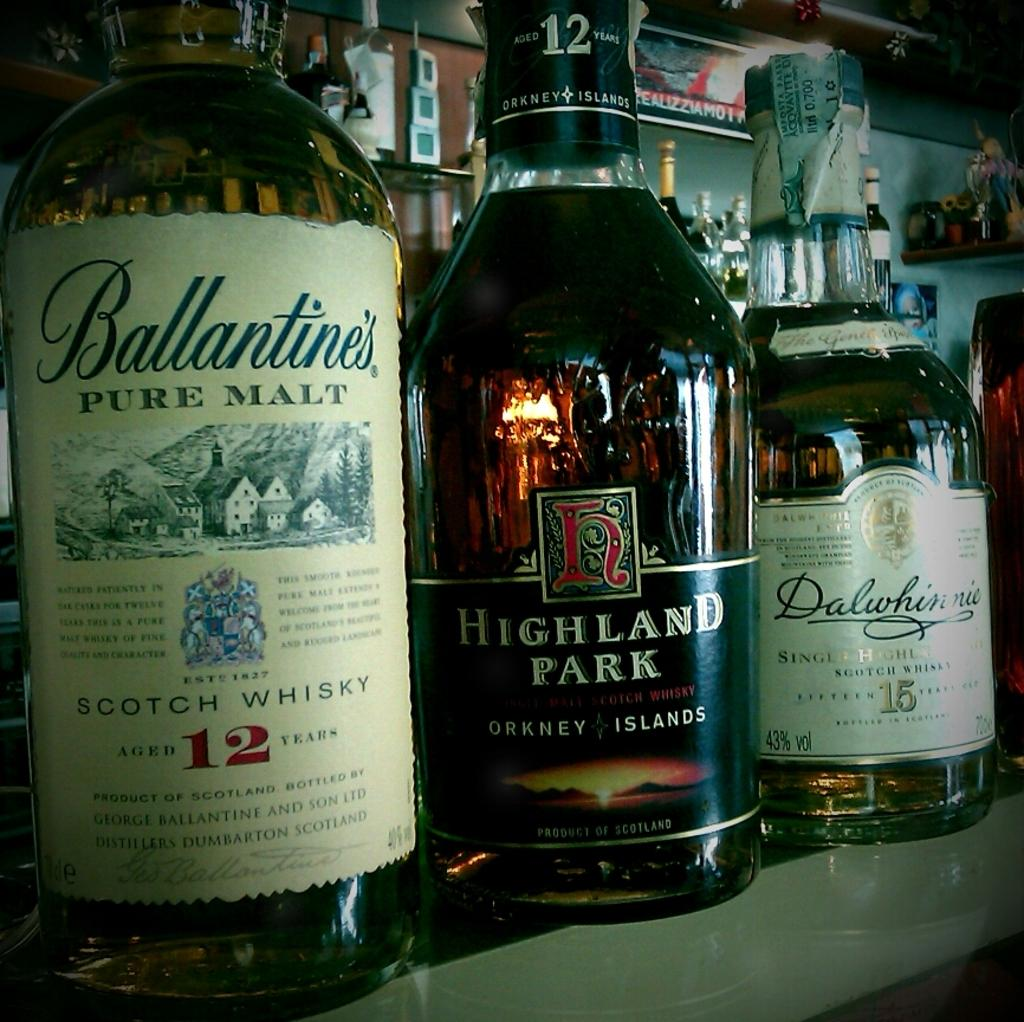<image>
Offer a succinct explanation of the picture presented. Three alcohol bottles next to one another with one that has the number 12 on it. 